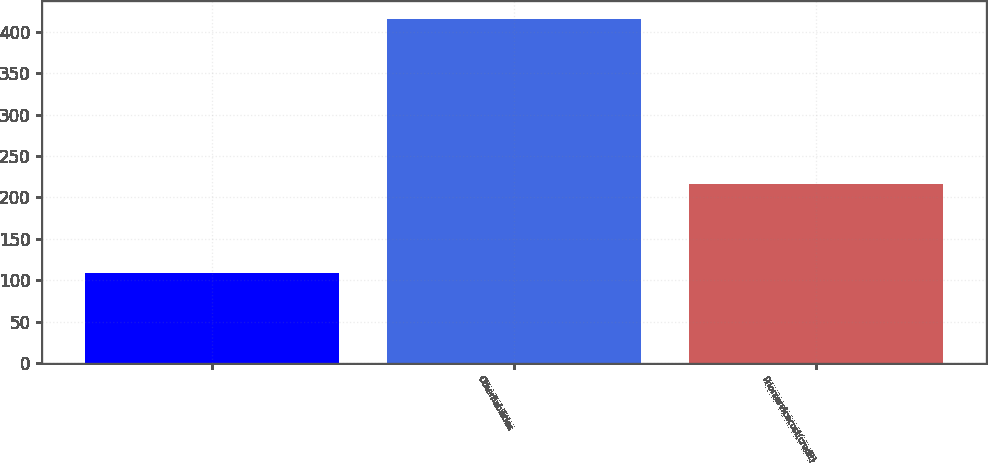Convert chart. <chart><loc_0><loc_0><loc_500><loc_500><bar_chart><ecel><fcel>Otherliabilities<fcel>Priorservicecost(credit)<nl><fcel>109<fcel>416<fcel>216.4<nl></chart> 